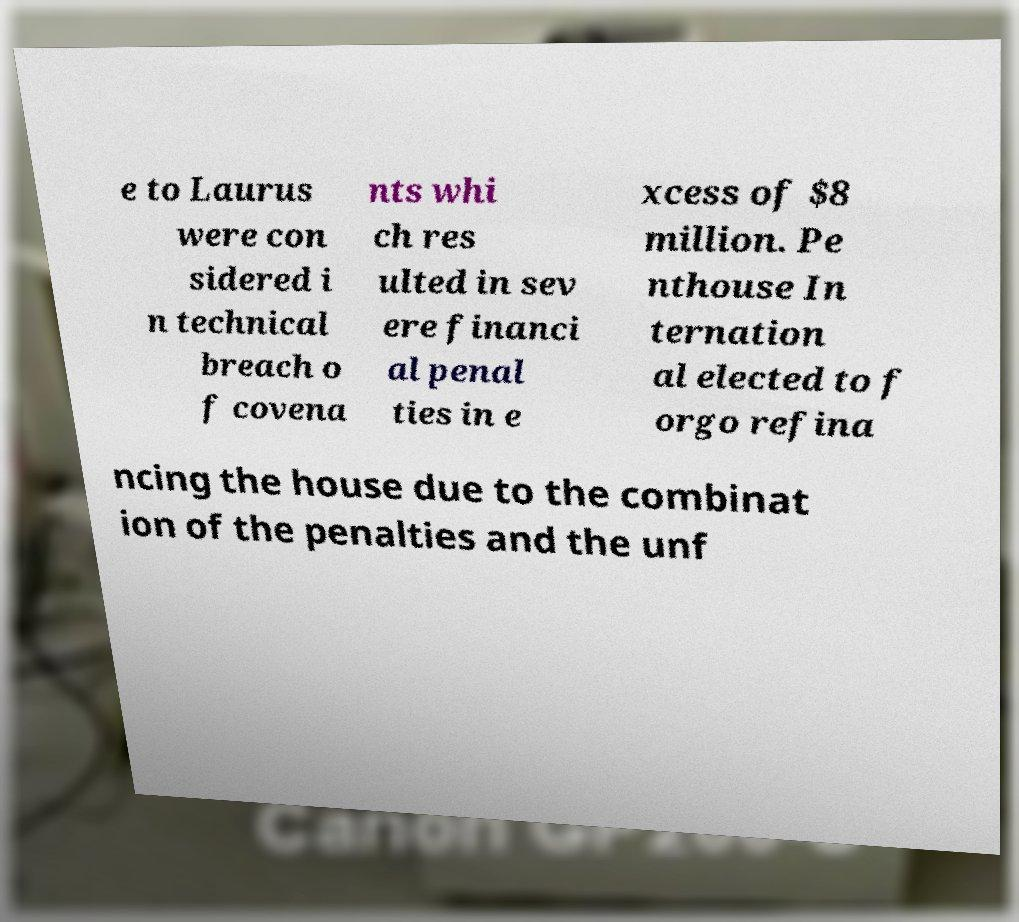Could you assist in decoding the text presented in this image and type it out clearly? e to Laurus were con sidered i n technical breach o f covena nts whi ch res ulted in sev ere financi al penal ties in e xcess of $8 million. Pe nthouse In ternation al elected to f orgo refina ncing the house due to the combinat ion of the penalties and the unf 